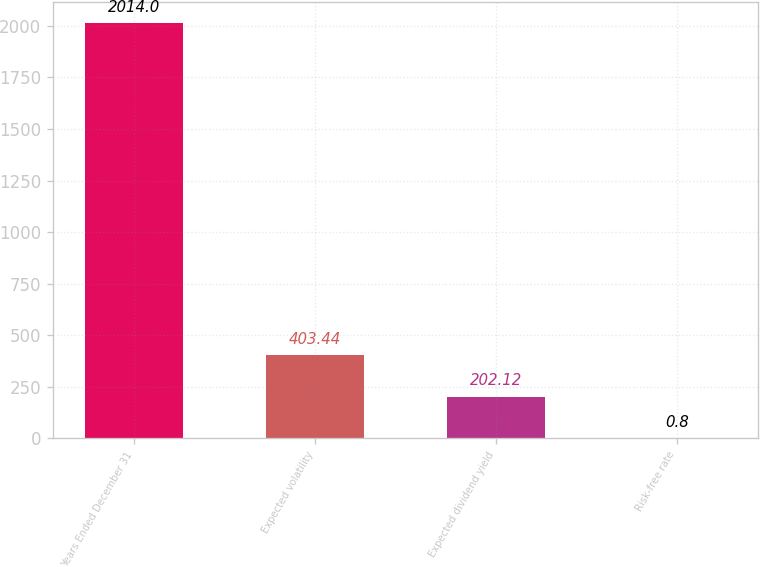<chart> <loc_0><loc_0><loc_500><loc_500><bar_chart><fcel>Years Ended December 31<fcel>Expected volatility<fcel>Expected dividend yield<fcel>Risk-free rate<nl><fcel>2014<fcel>403.44<fcel>202.12<fcel>0.8<nl></chart> 